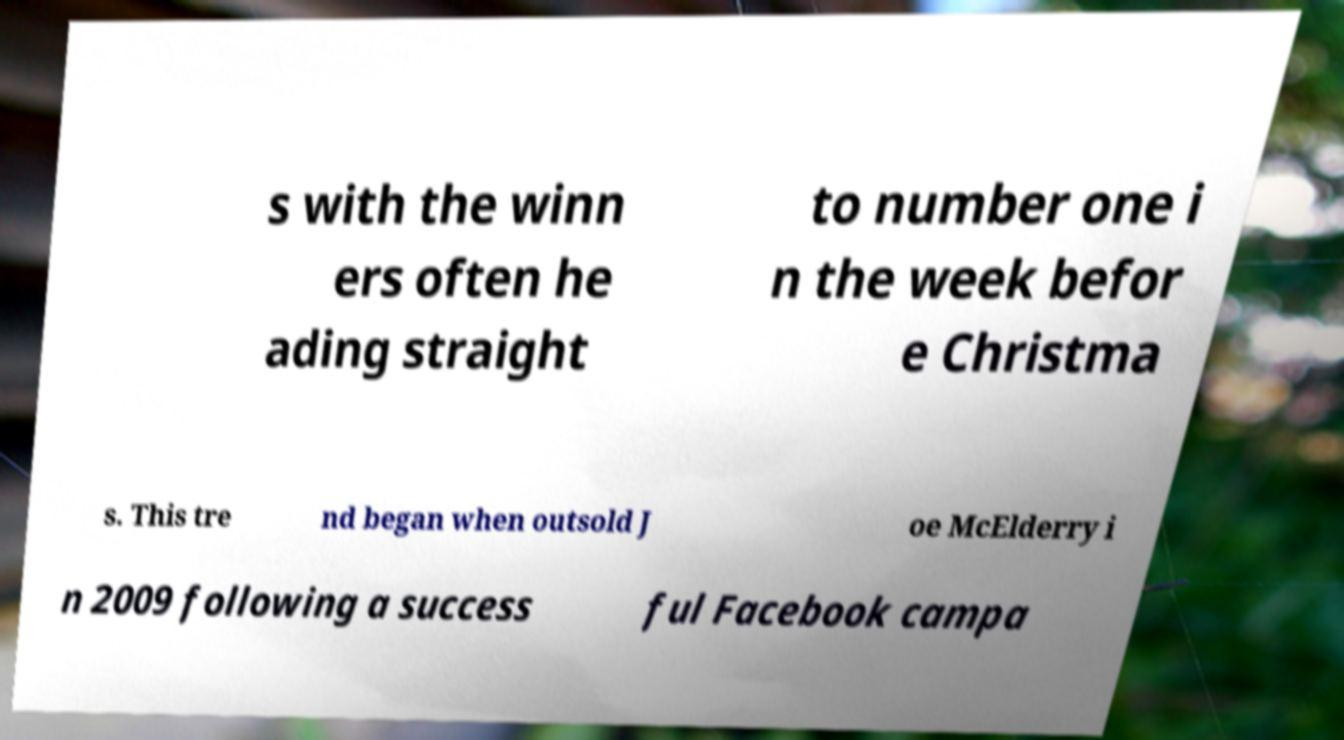Can you read and provide the text displayed in the image?This photo seems to have some interesting text. Can you extract and type it out for me? s with the winn ers often he ading straight to number one i n the week befor e Christma s. This tre nd began when outsold J oe McElderry i n 2009 following a success ful Facebook campa 